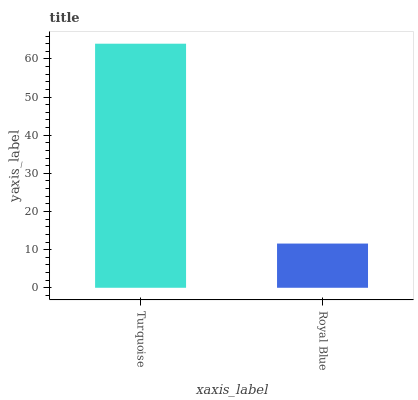Is Royal Blue the minimum?
Answer yes or no. Yes. Is Turquoise the maximum?
Answer yes or no. Yes. Is Royal Blue the maximum?
Answer yes or no. No. Is Turquoise greater than Royal Blue?
Answer yes or no. Yes. Is Royal Blue less than Turquoise?
Answer yes or no. Yes. Is Royal Blue greater than Turquoise?
Answer yes or no. No. Is Turquoise less than Royal Blue?
Answer yes or no. No. Is Turquoise the high median?
Answer yes or no. Yes. Is Royal Blue the low median?
Answer yes or no. Yes. Is Royal Blue the high median?
Answer yes or no. No. Is Turquoise the low median?
Answer yes or no. No. 